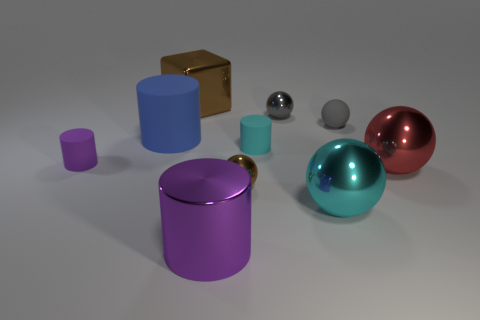Does the brown thing in front of the red object have the same material as the small sphere that is to the right of the cyan metal sphere?
Your answer should be compact. No. How many big blue cylinders are there?
Provide a succinct answer. 1. The small object on the right side of the cyan sphere has what shape?
Make the answer very short. Sphere. What number of other things are the same size as the gray matte ball?
Provide a succinct answer. 4. Do the small gray object that is in front of the gray shiny object and the red shiny thing that is behind the brown metal sphere have the same shape?
Keep it short and to the point. Yes. There is a tiny brown sphere; what number of small cylinders are behind it?
Offer a terse response. 2. There is a tiny metal sphere in front of the tiny cyan cylinder; what is its color?
Make the answer very short. Brown. What color is the large rubber thing that is the same shape as the small purple matte object?
Offer a very short reply. Blue. Is there anything else of the same color as the large matte thing?
Give a very brief answer. No. Are there more tiny brown matte objects than cyan balls?
Provide a succinct answer. No. 